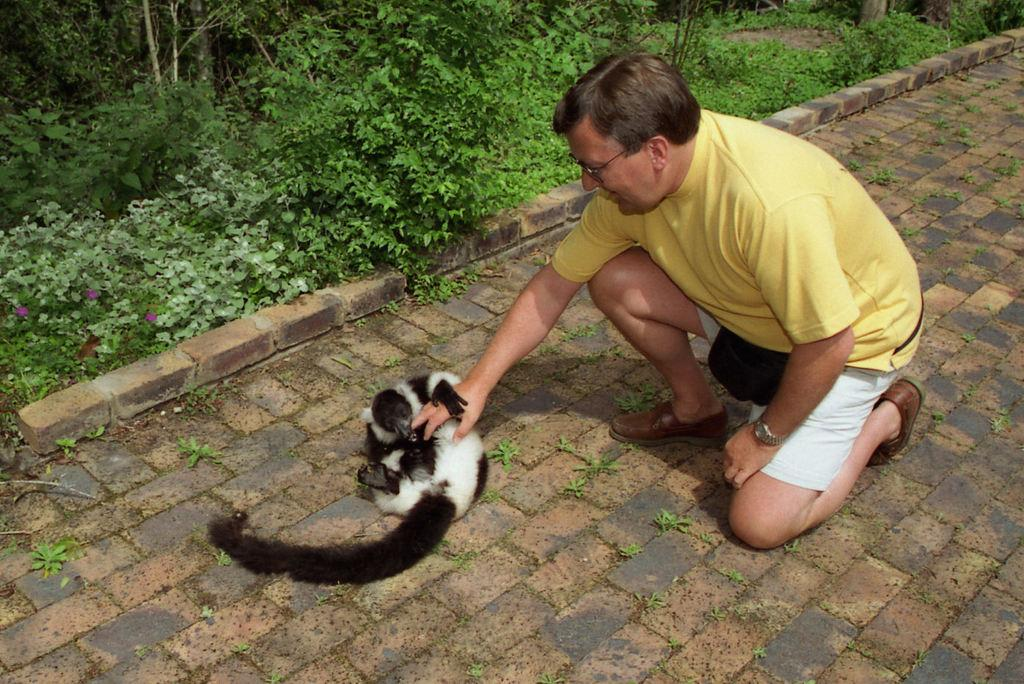What is the man in the image doing? The man is touching an animal in the image. What color is the man's t-shirt? The man is wearing a yellow t-shirt. What type of clothing is the man wearing on his lower body? The man is wearing shorts. What type of footwear is the man wearing? The man is wearing shoes. What type of surface is visible in the image? There is grass in the image. What type of vegetation is present in the image? There are plants in the image. What color are the man's eyes in the image? The provided facts do not mention the color of the man's eyes, so we cannot determine that information from the image. What type of camera is being used to take the picture? There is no camera present in the image, as it is a still photograph. 